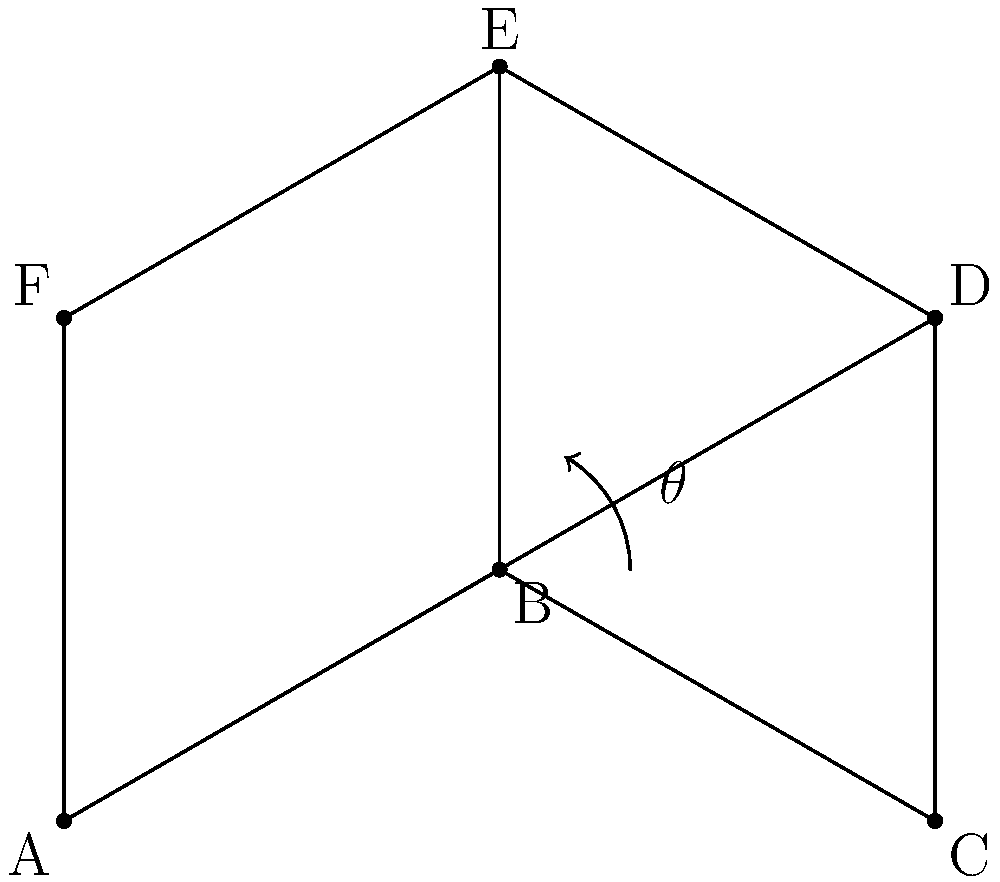In isometric projection for animation backgrounds, the angle between any two axes is typically 120°. Given this information, what is the angle $\theta$ between the horizontal line and the inclined line in the isometric cube shown above? To solve this problem, let's follow these steps:

1) In an isometric projection, the three axes are equally spaced at 120° angles.

2) This means that each axis is at a 30° angle from the horizontal or vertical.

3) In the given cube, we can see that angle $\theta$ is formed between the horizontal line AB and the inclined line BE.

4) The line BE represents one of the isometric axes.

5) Since each axis is at a 30° angle from the horizontal, we can conclude that:

   $$\theta = 30°$$

6) This angle is consistent across all similar edges in an isometric projection, which is why it's a fundamental aspect of creating depth and perspective in isometric animation backgrounds.

7) Understanding this angle is crucial for maintaining consistency in isometric designs and for accurately representing three-dimensional objects in a two-dimensional space.
Answer: 30° 